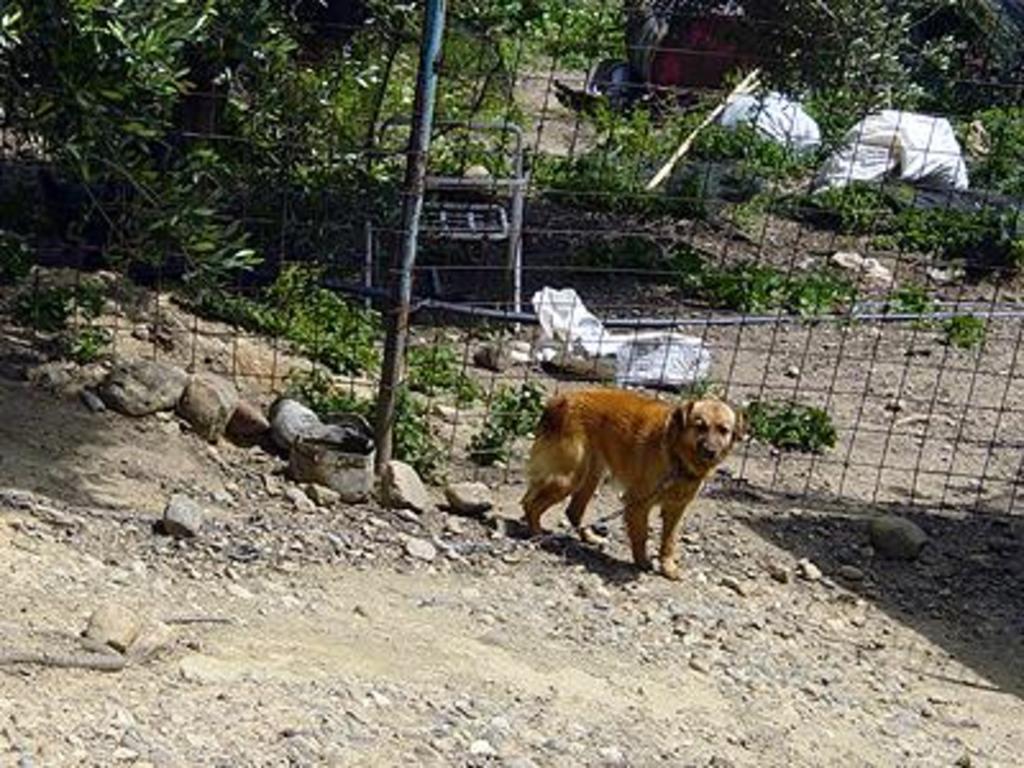Can you describe this image briefly? In this picture I can observe a dog in the middle of the picture. The dog is in brown color. There are some stones on the ground. Behind the dog there is a fence. In the background I can observe some plants and trees on the ground. 